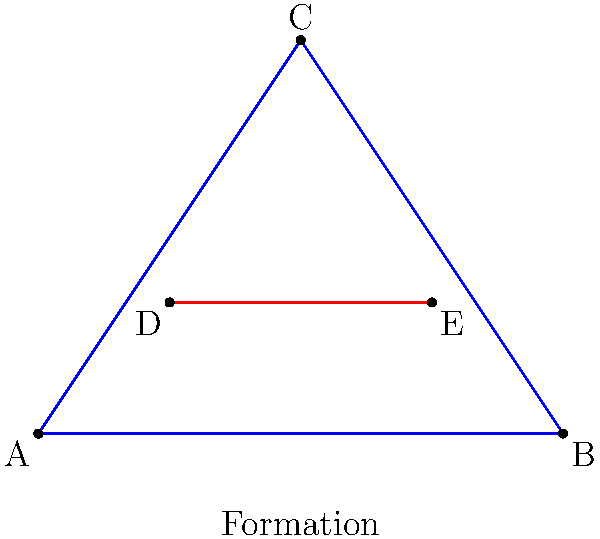In a set play formation inspired by Heath Scotland's strategic positioning, players form a triangle ABC with a line segment DE inside. If the area of triangle ABC is 6 square meters and the length of DE is 2 meters, what is the height of the triangle from point C to side AB? Let's approach this step-by-step:

1) We know that the area of a triangle is given by the formula:
   $$ \text{Area} = \frac{1}{2} \times \text{base} \times \text{height} $$

2) We are given that the area of triangle ABC is 6 square meters. Let's call the base (AB) $b$ and the height $h$. We can write:
   $$ 6 = \frac{1}{2} \times b \times h $$

3) Solving for $h$:
   $$ h = \frac{2 \times 6}{b} = \frac{12}{b} $$

4) We don't know the length of the base, but we can use the information about DE to find it. DE is parallel to AB and has a length of 2 meters.

5) In a triangle, any line segment parallel to the base divides the other two sides proportionally. If we assume DE divides the triangle into two equal parts (which is often a strategic formation in Australian football), then DE would be half the length of AB.

6) If DE is 2 meters and it's half of AB, then AB (the base) must be 4 meters.

7) Now we can substitute this into our equation for $h$:
   $$ h = \frac{12}{4} = 3 $$

Therefore, the height of the triangle from point C to side AB is 3 meters.
Answer: 3 meters 